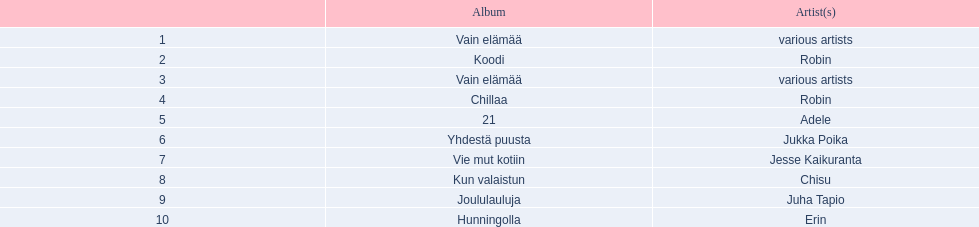Which albums had number-one albums in finland in 2012? 1, Vain elämää, Koodi, Vain elämää, Chillaa, 21, Yhdestä puusta, Vie mut kotiin, Kun valaistun, Joululauluja, Hunningolla. Of those albums, which were recorded by only one artist? Koodi, Chillaa, 21, Yhdestä puusta, Vie mut kotiin, Kun valaistun, Joululauluja, Hunningolla. Which albums made between 30,000 and 45,000 in sales? 21, Yhdestä puusta, Vie mut kotiin, Kun valaistun. Of those albums which had the highest sales? 21. Who was the artist for that album? Adele. 